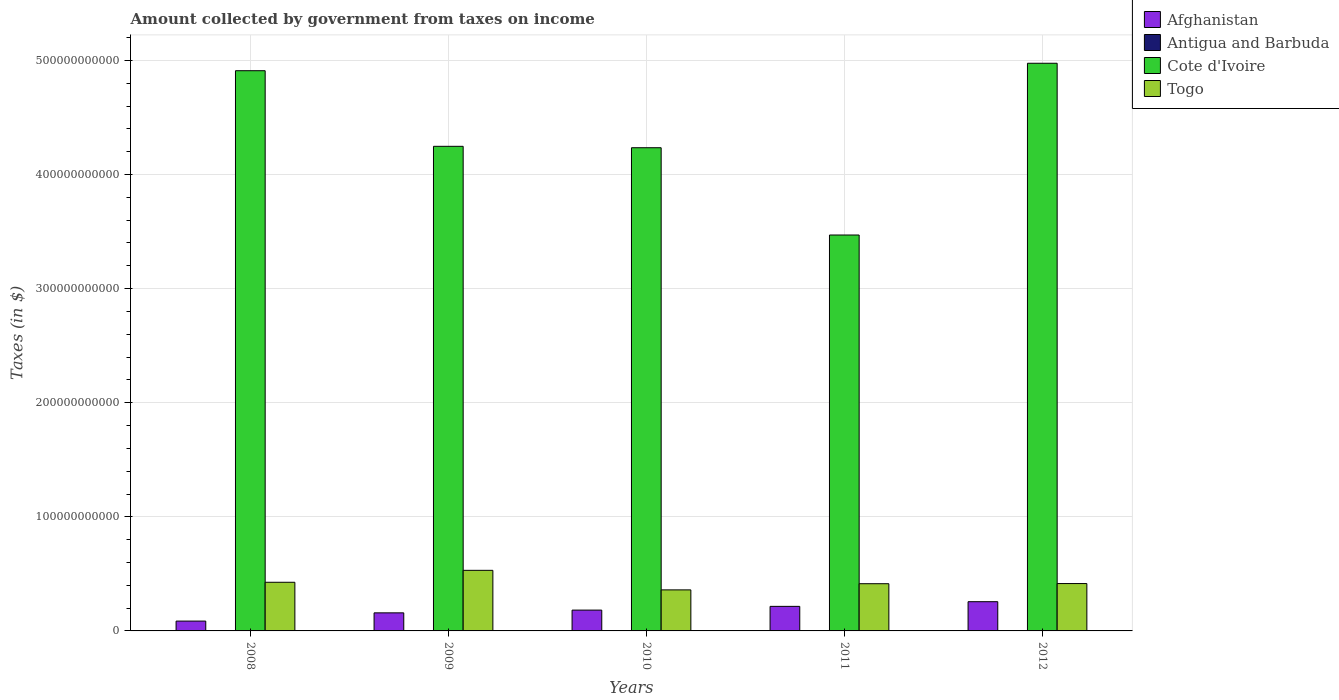How many groups of bars are there?
Your answer should be compact. 5. Are the number of bars per tick equal to the number of legend labels?
Provide a short and direct response. Yes. What is the label of the 1st group of bars from the left?
Offer a very short reply. 2008. In how many cases, is the number of bars for a given year not equal to the number of legend labels?
Provide a short and direct response. 0. What is the amount collected by government from taxes on income in Cote d'Ivoire in 2009?
Your answer should be very brief. 4.25e+11. Across all years, what is the maximum amount collected by government from taxes on income in Antigua and Barbuda?
Provide a short and direct response. 1.12e+08. Across all years, what is the minimum amount collected by government from taxes on income in Cote d'Ivoire?
Keep it short and to the point. 3.47e+11. In which year was the amount collected by government from taxes on income in Cote d'Ivoire minimum?
Provide a succinct answer. 2011. What is the total amount collected by government from taxes on income in Togo in the graph?
Offer a very short reply. 2.15e+11. What is the difference between the amount collected by government from taxes on income in Togo in 2008 and that in 2010?
Provide a short and direct response. 6.67e+09. What is the difference between the amount collected by government from taxes on income in Cote d'Ivoire in 2011 and the amount collected by government from taxes on income in Antigua and Barbuda in 2010?
Your answer should be very brief. 3.47e+11. What is the average amount collected by government from taxes on income in Togo per year?
Provide a short and direct response. 4.29e+1. In the year 2011, what is the difference between the amount collected by government from taxes on income in Antigua and Barbuda and amount collected by government from taxes on income in Afghanistan?
Your response must be concise. -2.14e+1. In how many years, is the amount collected by government from taxes on income in Togo greater than 60000000000 $?
Provide a short and direct response. 0. What is the ratio of the amount collected by government from taxes on income in Togo in 2008 to that in 2010?
Your answer should be very brief. 1.19. Is the difference between the amount collected by government from taxes on income in Antigua and Barbuda in 2008 and 2011 greater than the difference between the amount collected by government from taxes on income in Afghanistan in 2008 and 2011?
Keep it short and to the point. Yes. What is the difference between the highest and the second highest amount collected by government from taxes on income in Afghanistan?
Your answer should be very brief. 4.09e+09. What is the difference between the highest and the lowest amount collected by government from taxes on income in Afghanistan?
Give a very brief answer. 1.70e+1. What does the 1st bar from the left in 2010 represents?
Make the answer very short. Afghanistan. What does the 3rd bar from the right in 2009 represents?
Give a very brief answer. Antigua and Barbuda. How many bars are there?
Keep it short and to the point. 20. How many years are there in the graph?
Offer a very short reply. 5. What is the difference between two consecutive major ticks on the Y-axis?
Make the answer very short. 1.00e+11. Does the graph contain grids?
Your answer should be very brief. Yes. Where does the legend appear in the graph?
Provide a short and direct response. Top right. How many legend labels are there?
Make the answer very short. 4. How are the legend labels stacked?
Offer a very short reply. Vertical. What is the title of the graph?
Your answer should be very brief. Amount collected by government from taxes on income. Does "Ukraine" appear as one of the legend labels in the graph?
Give a very brief answer. No. What is the label or title of the X-axis?
Your response must be concise. Years. What is the label or title of the Y-axis?
Provide a short and direct response. Taxes (in $). What is the Taxes (in $) of Afghanistan in 2008?
Provide a succinct answer. 8.62e+09. What is the Taxes (in $) of Antigua and Barbuda in 2008?
Provide a succinct answer. 1.12e+08. What is the Taxes (in $) of Cote d'Ivoire in 2008?
Offer a terse response. 4.91e+11. What is the Taxes (in $) in Togo in 2008?
Your answer should be compact. 4.26e+1. What is the Taxes (in $) of Afghanistan in 2009?
Offer a terse response. 1.58e+1. What is the Taxes (in $) in Antigua and Barbuda in 2009?
Keep it short and to the point. 9.80e+07. What is the Taxes (in $) of Cote d'Ivoire in 2009?
Ensure brevity in your answer.  4.25e+11. What is the Taxes (in $) in Togo in 2009?
Provide a short and direct response. 5.31e+1. What is the Taxes (in $) in Afghanistan in 2010?
Offer a very short reply. 1.82e+1. What is the Taxes (in $) of Antigua and Barbuda in 2010?
Give a very brief answer. 9.24e+07. What is the Taxes (in $) in Cote d'Ivoire in 2010?
Give a very brief answer. 4.24e+11. What is the Taxes (in $) in Togo in 2010?
Offer a terse response. 3.60e+1. What is the Taxes (in $) in Afghanistan in 2011?
Ensure brevity in your answer.  2.15e+1. What is the Taxes (in $) in Antigua and Barbuda in 2011?
Your response must be concise. 6.97e+07. What is the Taxes (in $) in Cote d'Ivoire in 2011?
Keep it short and to the point. 3.47e+11. What is the Taxes (in $) in Togo in 2011?
Make the answer very short. 4.14e+1. What is the Taxes (in $) in Afghanistan in 2012?
Provide a short and direct response. 2.56e+1. What is the Taxes (in $) of Antigua and Barbuda in 2012?
Offer a very short reply. 7.73e+07. What is the Taxes (in $) of Cote d'Ivoire in 2012?
Your response must be concise. 4.98e+11. What is the Taxes (in $) of Togo in 2012?
Provide a succinct answer. 4.15e+1. Across all years, what is the maximum Taxes (in $) in Afghanistan?
Make the answer very short. 2.56e+1. Across all years, what is the maximum Taxes (in $) of Antigua and Barbuda?
Make the answer very short. 1.12e+08. Across all years, what is the maximum Taxes (in $) in Cote d'Ivoire?
Offer a terse response. 4.98e+11. Across all years, what is the maximum Taxes (in $) in Togo?
Give a very brief answer. 5.31e+1. Across all years, what is the minimum Taxes (in $) of Afghanistan?
Offer a very short reply. 8.62e+09. Across all years, what is the minimum Taxes (in $) of Antigua and Barbuda?
Offer a terse response. 6.97e+07. Across all years, what is the minimum Taxes (in $) of Cote d'Ivoire?
Your answer should be very brief. 3.47e+11. Across all years, what is the minimum Taxes (in $) of Togo?
Ensure brevity in your answer.  3.60e+1. What is the total Taxes (in $) in Afghanistan in the graph?
Give a very brief answer. 8.98e+1. What is the total Taxes (in $) in Antigua and Barbuda in the graph?
Make the answer very short. 4.49e+08. What is the total Taxes (in $) in Cote d'Ivoire in the graph?
Your answer should be very brief. 2.18e+12. What is the total Taxes (in $) of Togo in the graph?
Offer a terse response. 2.15e+11. What is the difference between the Taxes (in $) in Afghanistan in 2008 and that in 2009?
Your answer should be very brief. -7.23e+09. What is the difference between the Taxes (in $) in Antigua and Barbuda in 2008 and that in 2009?
Keep it short and to the point. 1.35e+07. What is the difference between the Taxes (in $) of Cote d'Ivoire in 2008 and that in 2009?
Provide a short and direct response. 6.63e+1. What is the difference between the Taxes (in $) in Togo in 2008 and that in 2009?
Make the answer very short. -1.05e+1. What is the difference between the Taxes (in $) in Afghanistan in 2008 and that in 2010?
Your response must be concise. -9.63e+09. What is the difference between the Taxes (in $) in Antigua and Barbuda in 2008 and that in 2010?
Make the answer very short. 1.91e+07. What is the difference between the Taxes (in $) of Cote d'Ivoire in 2008 and that in 2010?
Your answer should be compact. 6.75e+1. What is the difference between the Taxes (in $) of Togo in 2008 and that in 2010?
Keep it short and to the point. 6.67e+09. What is the difference between the Taxes (in $) in Afghanistan in 2008 and that in 2011?
Keep it short and to the point. -1.29e+1. What is the difference between the Taxes (in $) in Antigua and Barbuda in 2008 and that in 2011?
Your answer should be compact. 4.18e+07. What is the difference between the Taxes (in $) in Cote d'Ivoire in 2008 and that in 2011?
Give a very brief answer. 1.44e+11. What is the difference between the Taxes (in $) in Togo in 2008 and that in 2011?
Give a very brief answer. 1.26e+09. What is the difference between the Taxes (in $) of Afghanistan in 2008 and that in 2012?
Provide a short and direct response. -1.70e+1. What is the difference between the Taxes (in $) in Antigua and Barbuda in 2008 and that in 2012?
Your answer should be very brief. 3.42e+07. What is the difference between the Taxes (in $) in Cote d'Ivoire in 2008 and that in 2012?
Offer a terse response. -6.53e+09. What is the difference between the Taxes (in $) of Togo in 2008 and that in 2012?
Keep it short and to the point. 1.12e+09. What is the difference between the Taxes (in $) of Afghanistan in 2009 and that in 2010?
Your answer should be compact. -2.41e+09. What is the difference between the Taxes (in $) in Antigua and Barbuda in 2009 and that in 2010?
Your answer should be compact. 5.60e+06. What is the difference between the Taxes (in $) of Cote d'Ivoire in 2009 and that in 2010?
Your answer should be compact. 1.24e+09. What is the difference between the Taxes (in $) in Togo in 2009 and that in 2010?
Your response must be concise. 1.71e+1. What is the difference between the Taxes (in $) of Afghanistan in 2009 and that in 2011?
Make the answer very short. -5.68e+09. What is the difference between the Taxes (in $) in Antigua and Barbuda in 2009 and that in 2011?
Keep it short and to the point. 2.83e+07. What is the difference between the Taxes (in $) in Cote d'Ivoire in 2009 and that in 2011?
Give a very brief answer. 7.77e+1. What is the difference between the Taxes (in $) of Togo in 2009 and that in 2011?
Provide a short and direct response. 1.17e+1. What is the difference between the Taxes (in $) in Afghanistan in 2009 and that in 2012?
Give a very brief answer. -9.77e+09. What is the difference between the Taxes (in $) in Antigua and Barbuda in 2009 and that in 2012?
Ensure brevity in your answer.  2.07e+07. What is the difference between the Taxes (in $) in Cote d'Ivoire in 2009 and that in 2012?
Your response must be concise. -7.28e+1. What is the difference between the Taxes (in $) in Togo in 2009 and that in 2012?
Keep it short and to the point. 1.16e+1. What is the difference between the Taxes (in $) of Afghanistan in 2010 and that in 2011?
Your answer should be very brief. -3.27e+09. What is the difference between the Taxes (in $) of Antigua and Barbuda in 2010 and that in 2011?
Make the answer very short. 2.27e+07. What is the difference between the Taxes (in $) in Cote d'Ivoire in 2010 and that in 2011?
Your answer should be very brief. 7.65e+1. What is the difference between the Taxes (in $) in Togo in 2010 and that in 2011?
Provide a short and direct response. -5.41e+09. What is the difference between the Taxes (in $) of Afghanistan in 2010 and that in 2012?
Make the answer very short. -7.36e+09. What is the difference between the Taxes (in $) of Antigua and Barbuda in 2010 and that in 2012?
Offer a very short reply. 1.51e+07. What is the difference between the Taxes (in $) in Cote d'Ivoire in 2010 and that in 2012?
Offer a very short reply. -7.40e+1. What is the difference between the Taxes (in $) in Togo in 2010 and that in 2012?
Provide a short and direct response. -5.55e+09. What is the difference between the Taxes (in $) of Afghanistan in 2011 and that in 2012?
Provide a short and direct response. -4.09e+09. What is the difference between the Taxes (in $) of Antigua and Barbuda in 2011 and that in 2012?
Give a very brief answer. -7.60e+06. What is the difference between the Taxes (in $) of Cote d'Ivoire in 2011 and that in 2012?
Your answer should be compact. -1.51e+11. What is the difference between the Taxes (in $) in Togo in 2011 and that in 2012?
Offer a terse response. -1.35e+08. What is the difference between the Taxes (in $) of Afghanistan in 2008 and the Taxes (in $) of Antigua and Barbuda in 2009?
Ensure brevity in your answer.  8.52e+09. What is the difference between the Taxes (in $) in Afghanistan in 2008 and the Taxes (in $) in Cote d'Ivoire in 2009?
Your response must be concise. -4.16e+11. What is the difference between the Taxes (in $) of Afghanistan in 2008 and the Taxes (in $) of Togo in 2009?
Provide a succinct answer. -4.45e+1. What is the difference between the Taxes (in $) in Antigua and Barbuda in 2008 and the Taxes (in $) in Cote d'Ivoire in 2009?
Offer a very short reply. -4.25e+11. What is the difference between the Taxes (in $) of Antigua and Barbuda in 2008 and the Taxes (in $) of Togo in 2009?
Keep it short and to the point. -5.30e+1. What is the difference between the Taxes (in $) of Cote d'Ivoire in 2008 and the Taxes (in $) of Togo in 2009?
Give a very brief answer. 4.38e+11. What is the difference between the Taxes (in $) of Afghanistan in 2008 and the Taxes (in $) of Antigua and Barbuda in 2010?
Your answer should be very brief. 8.52e+09. What is the difference between the Taxes (in $) of Afghanistan in 2008 and the Taxes (in $) of Cote d'Ivoire in 2010?
Make the answer very short. -4.15e+11. What is the difference between the Taxes (in $) of Afghanistan in 2008 and the Taxes (in $) of Togo in 2010?
Offer a terse response. -2.74e+1. What is the difference between the Taxes (in $) of Antigua and Barbuda in 2008 and the Taxes (in $) of Cote d'Ivoire in 2010?
Offer a very short reply. -4.23e+11. What is the difference between the Taxes (in $) in Antigua and Barbuda in 2008 and the Taxes (in $) in Togo in 2010?
Provide a succinct answer. -3.59e+1. What is the difference between the Taxes (in $) in Cote d'Ivoire in 2008 and the Taxes (in $) in Togo in 2010?
Provide a short and direct response. 4.55e+11. What is the difference between the Taxes (in $) in Afghanistan in 2008 and the Taxes (in $) in Antigua and Barbuda in 2011?
Keep it short and to the point. 8.55e+09. What is the difference between the Taxes (in $) of Afghanistan in 2008 and the Taxes (in $) of Cote d'Ivoire in 2011?
Your answer should be compact. -3.38e+11. What is the difference between the Taxes (in $) of Afghanistan in 2008 and the Taxes (in $) of Togo in 2011?
Offer a very short reply. -3.28e+1. What is the difference between the Taxes (in $) of Antigua and Barbuda in 2008 and the Taxes (in $) of Cote d'Ivoire in 2011?
Your answer should be compact. -3.47e+11. What is the difference between the Taxes (in $) of Antigua and Barbuda in 2008 and the Taxes (in $) of Togo in 2011?
Ensure brevity in your answer.  -4.13e+1. What is the difference between the Taxes (in $) in Cote d'Ivoire in 2008 and the Taxes (in $) in Togo in 2011?
Your response must be concise. 4.50e+11. What is the difference between the Taxes (in $) in Afghanistan in 2008 and the Taxes (in $) in Antigua and Barbuda in 2012?
Give a very brief answer. 8.54e+09. What is the difference between the Taxes (in $) in Afghanistan in 2008 and the Taxes (in $) in Cote d'Ivoire in 2012?
Provide a succinct answer. -4.89e+11. What is the difference between the Taxes (in $) of Afghanistan in 2008 and the Taxes (in $) of Togo in 2012?
Make the answer very short. -3.29e+1. What is the difference between the Taxes (in $) of Antigua and Barbuda in 2008 and the Taxes (in $) of Cote d'Ivoire in 2012?
Give a very brief answer. -4.97e+11. What is the difference between the Taxes (in $) in Antigua and Barbuda in 2008 and the Taxes (in $) in Togo in 2012?
Your response must be concise. -4.14e+1. What is the difference between the Taxes (in $) of Cote d'Ivoire in 2008 and the Taxes (in $) of Togo in 2012?
Your answer should be compact. 4.49e+11. What is the difference between the Taxes (in $) in Afghanistan in 2009 and the Taxes (in $) in Antigua and Barbuda in 2010?
Your response must be concise. 1.57e+1. What is the difference between the Taxes (in $) of Afghanistan in 2009 and the Taxes (in $) of Cote d'Ivoire in 2010?
Your answer should be compact. -4.08e+11. What is the difference between the Taxes (in $) in Afghanistan in 2009 and the Taxes (in $) in Togo in 2010?
Provide a succinct answer. -2.01e+1. What is the difference between the Taxes (in $) of Antigua and Barbuda in 2009 and the Taxes (in $) of Cote d'Ivoire in 2010?
Give a very brief answer. -4.23e+11. What is the difference between the Taxes (in $) in Antigua and Barbuda in 2009 and the Taxes (in $) in Togo in 2010?
Give a very brief answer. -3.59e+1. What is the difference between the Taxes (in $) of Cote d'Ivoire in 2009 and the Taxes (in $) of Togo in 2010?
Your answer should be compact. 3.89e+11. What is the difference between the Taxes (in $) of Afghanistan in 2009 and the Taxes (in $) of Antigua and Barbuda in 2011?
Your answer should be compact. 1.58e+1. What is the difference between the Taxes (in $) in Afghanistan in 2009 and the Taxes (in $) in Cote d'Ivoire in 2011?
Offer a terse response. -3.31e+11. What is the difference between the Taxes (in $) of Afghanistan in 2009 and the Taxes (in $) of Togo in 2011?
Your response must be concise. -2.55e+1. What is the difference between the Taxes (in $) of Antigua and Barbuda in 2009 and the Taxes (in $) of Cote d'Ivoire in 2011?
Offer a terse response. -3.47e+11. What is the difference between the Taxes (in $) of Antigua and Barbuda in 2009 and the Taxes (in $) of Togo in 2011?
Provide a short and direct response. -4.13e+1. What is the difference between the Taxes (in $) of Cote d'Ivoire in 2009 and the Taxes (in $) of Togo in 2011?
Offer a terse response. 3.83e+11. What is the difference between the Taxes (in $) of Afghanistan in 2009 and the Taxes (in $) of Antigua and Barbuda in 2012?
Ensure brevity in your answer.  1.58e+1. What is the difference between the Taxes (in $) in Afghanistan in 2009 and the Taxes (in $) in Cote d'Ivoire in 2012?
Keep it short and to the point. -4.82e+11. What is the difference between the Taxes (in $) of Afghanistan in 2009 and the Taxes (in $) of Togo in 2012?
Make the answer very short. -2.57e+1. What is the difference between the Taxes (in $) of Antigua and Barbuda in 2009 and the Taxes (in $) of Cote d'Ivoire in 2012?
Provide a short and direct response. -4.97e+11. What is the difference between the Taxes (in $) of Antigua and Barbuda in 2009 and the Taxes (in $) of Togo in 2012?
Give a very brief answer. -4.14e+1. What is the difference between the Taxes (in $) of Cote d'Ivoire in 2009 and the Taxes (in $) of Togo in 2012?
Provide a succinct answer. 3.83e+11. What is the difference between the Taxes (in $) in Afghanistan in 2010 and the Taxes (in $) in Antigua and Barbuda in 2011?
Your answer should be compact. 1.82e+1. What is the difference between the Taxes (in $) in Afghanistan in 2010 and the Taxes (in $) in Cote d'Ivoire in 2011?
Offer a terse response. -3.29e+11. What is the difference between the Taxes (in $) of Afghanistan in 2010 and the Taxes (in $) of Togo in 2011?
Provide a succinct answer. -2.31e+1. What is the difference between the Taxes (in $) of Antigua and Barbuda in 2010 and the Taxes (in $) of Cote d'Ivoire in 2011?
Provide a short and direct response. -3.47e+11. What is the difference between the Taxes (in $) in Antigua and Barbuda in 2010 and the Taxes (in $) in Togo in 2011?
Make the answer very short. -4.13e+1. What is the difference between the Taxes (in $) in Cote d'Ivoire in 2010 and the Taxes (in $) in Togo in 2011?
Your response must be concise. 3.82e+11. What is the difference between the Taxes (in $) of Afghanistan in 2010 and the Taxes (in $) of Antigua and Barbuda in 2012?
Offer a very short reply. 1.82e+1. What is the difference between the Taxes (in $) in Afghanistan in 2010 and the Taxes (in $) in Cote d'Ivoire in 2012?
Offer a terse response. -4.79e+11. What is the difference between the Taxes (in $) in Afghanistan in 2010 and the Taxes (in $) in Togo in 2012?
Ensure brevity in your answer.  -2.33e+1. What is the difference between the Taxes (in $) in Antigua and Barbuda in 2010 and the Taxes (in $) in Cote d'Ivoire in 2012?
Your answer should be very brief. -4.97e+11. What is the difference between the Taxes (in $) in Antigua and Barbuda in 2010 and the Taxes (in $) in Togo in 2012?
Offer a very short reply. -4.14e+1. What is the difference between the Taxes (in $) of Cote d'Ivoire in 2010 and the Taxes (in $) of Togo in 2012?
Provide a short and direct response. 3.82e+11. What is the difference between the Taxes (in $) of Afghanistan in 2011 and the Taxes (in $) of Antigua and Barbuda in 2012?
Your answer should be very brief. 2.14e+1. What is the difference between the Taxes (in $) in Afghanistan in 2011 and the Taxes (in $) in Cote d'Ivoire in 2012?
Give a very brief answer. -4.76e+11. What is the difference between the Taxes (in $) of Afghanistan in 2011 and the Taxes (in $) of Togo in 2012?
Make the answer very short. -2.00e+1. What is the difference between the Taxes (in $) in Antigua and Barbuda in 2011 and the Taxes (in $) in Cote d'Ivoire in 2012?
Offer a terse response. -4.97e+11. What is the difference between the Taxes (in $) in Antigua and Barbuda in 2011 and the Taxes (in $) in Togo in 2012?
Give a very brief answer. -4.14e+1. What is the difference between the Taxes (in $) of Cote d'Ivoire in 2011 and the Taxes (in $) of Togo in 2012?
Provide a short and direct response. 3.05e+11. What is the average Taxes (in $) in Afghanistan per year?
Your answer should be compact. 1.80e+1. What is the average Taxes (in $) in Antigua and Barbuda per year?
Offer a terse response. 8.98e+07. What is the average Taxes (in $) in Cote d'Ivoire per year?
Your answer should be very brief. 4.37e+11. What is the average Taxes (in $) in Togo per year?
Your answer should be very brief. 4.29e+1. In the year 2008, what is the difference between the Taxes (in $) of Afghanistan and Taxes (in $) of Antigua and Barbuda?
Offer a very short reply. 8.50e+09. In the year 2008, what is the difference between the Taxes (in $) of Afghanistan and Taxes (in $) of Cote d'Ivoire?
Offer a very short reply. -4.82e+11. In the year 2008, what is the difference between the Taxes (in $) in Afghanistan and Taxes (in $) in Togo?
Ensure brevity in your answer.  -3.40e+1. In the year 2008, what is the difference between the Taxes (in $) in Antigua and Barbuda and Taxes (in $) in Cote d'Ivoire?
Provide a short and direct response. -4.91e+11. In the year 2008, what is the difference between the Taxes (in $) of Antigua and Barbuda and Taxes (in $) of Togo?
Your response must be concise. -4.25e+1. In the year 2008, what is the difference between the Taxes (in $) in Cote d'Ivoire and Taxes (in $) in Togo?
Offer a terse response. 4.48e+11. In the year 2009, what is the difference between the Taxes (in $) in Afghanistan and Taxes (in $) in Antigua and Barbuda?
Provide a short and direct response. 1.57e+1. In the year 2009, what is the difference between the Taxes (in $) of Afghanistan and Taxes (in $) of Cote d'Ivoire?
Offer a terse response. -4.09e+11. In the year 2009, what is the difference between the Taxes (in $) of Afghanistan and Taxes (in $) of Togo?
Make the answer very short. -3.73e+1. In the year 2009, what is the difference between the Taxes (in $) of Antigua and Barbuda and Taxes (in $) of Cote d'Ivoire?
Provide a short and direct response. -4.25e+11. In the year 2009, what is the difference between the Taxes (in $) of Antigua and Barbuda and Taxes (in $) of Togo?
Ensure brevity in your answer.  -5.30e+1. In the year 2009, what is the difference between the Taxes (in $) of Cote d'Ivoire and Taxes (in $) of Togo?
Make the answer very short. 3.72e+11. In the year 2010, what is the difference between the Taxes (in $) in Afghanistan and Taxes (in $) in Antigua and Barbuda?
Ensure brevity in your answer.  1.82e+1. In the year 2010, what is the difference between the Taxes (in $) in Afghanistan and Taxes (in $) in Cote d'Ivoire?
Provide a succinct answer. -4.05e+11. In the year 2010, what is the difference between the Taxes (in $) of Afghanistan and Taxes (in $) of Togo?
Ensure brevity in your answer.  -1.77e+1. In the year 2010, what is the difference between the Taxes (in $) in Antigua and Barbuda and Taxes (in $) in Cote d'Ivoire?
Make the answer very short. -4.23e+11. In the year 2010, what is the difference between the Taxes (in $) of Antigua and Barbuda and Taxes (in $) of Togo?
Offer a terse response. -3.59e+1. In the year 2010, what is the difference between the Taxes (in $) in Cote d'Ivoire and Taxes (in $) in Togo?
Give a very brief answer. 3.88e+11. In the year 2011, what is the difference between the Taxes (in $) of Afghanistan and Taxes (in $) of Antigua and Barbuda?
Give a very brief answer. 2.14e+1. In the year 2011, what is the difference between the Taxes (in $) in Afghanistan and Taxes (in $) in Cote d'Ivoire?
Provide a succinct answer. -3.25e+11. In the year 2011, what is the difference between the Taxes (in $) of Afghanistan and Taxes (in $) of Togo?
Offer a terse response. -1.99e+1. In the year 2011, what is the difference between the Taxes (in $) of Antigua and Barbuda and Taxes (in $) of Cote d'Ivoire?
Ensure brevity in your answer.  -3.47e+11. In the year 2011, what is the difference between the Taxes (in $) of Antigua and Barbuda and Taxes (in $) of Togo?
Provide a short and direct response. -4.13e+1. In the year 2011, what is the difference between the Taxes (in $) of Cote d'Ivoire and Taxes (in $) of Togo?
Offer a very short reply. 3.06e+11. In the year 2012, what is the difference between the Taxes (in $) in Afghanistan and Taxes (in $) in Antigua and Barbuda?
Ensure brevity in your answer.  2.55e+1. In the year 2012, what is the difference between the Taxes (in $) in Afghanistan and Taxes (in $) in Cote d'Ivoire?
Make the answer very short. -4.72e+11. In the year 2012, what is the difference between the Taxes (in $) in Afghanistan and Taxes (in $) in Togo?
Offer a terse response. -1.59e+1. In the year 2012, what is the difference between the Taxes (in $) in Antigua and Barbuda and Taxes (in $) in Cote d'Ivoire?
Provide a succinct answer. -4.97e+11. In the year 2012, what is the difference between the Taxes (in $) in Antigua and Barbuda and Taxes (in $) in Togo?
Your response must be concise. -4.14e+1. In the year 2012, what is the difference between the Taxes (in $) of Cote d'Ivoire and Taxes (in $) of Togo?
Offer a terse response. 4.56e+11. What is the ratio of the Taxes (in $) in Afghanistan in 2008 to that in 2009?
Offer a very short reply. 0.54. What is the ratio of the Taxes (in $) of Antigua and Barbuda in 2008 to that in 2009?
Provide a short and direct response. 1.14. What is the ratio of the Taxes (in $) in Cote d'Ivoire in 2008 to that in 2009?
Your answer should be very brief. 1.16. What is the ratio of the Taxes (in $) in Togo in 2008 to that in 2009?
Offer a very short reply. 0.8. What is the ratio of the Taxes (in $) of Afghanistan in 2008 to that in 2010?
Ensure brevity in your answer.  0.47. What is the ratio of the Taxes (in $) of Antigua and Barbuda in 2008 to that in 2010?
Make the answer very short. 1.21. What is the ratio of the Taxes (in $) in Cote d'Ivoire in 2008 to that in 2010?
Make the answer very short. 1.16. What is the ratio of the Taxes (in $) of Togo in 2008 to that in 2010?
Give a very brief answer. 1.19. What is the ratio of the Taxes (in $) in Afghanistan in 2008 to that in 2011?
Keep it short and to the point. 0.4. What is the ratio of the Taxes (in $) in Antigua and Barbuda in 2008 to that in 2011?
Make the answer very short. 1.6. What is the ratio of the Taxes (in $) in Cote d'Ivoire in 2008 to that in 2011?
Provide a short and direct response. 1.42. What is the ratio of the Taxes (in $) of Togo in 2008 to that in 2011?
Your answer should be very brief. 1.03. What is the ratio of the Taxes (in $) of Afghanistan in 2008 to that in 2012?
Offer a terse response. 0.34. What is the ratio of the Taxes (in $) in Antigua and Barbuda in 2008 to that in 2012?
Provide a short and direct response. 1.44. What is the ratio of the Taxes (in $) of Cote d'Ivoire in 2008 to that in 2012?
Your answer should be compact. 0.99. What is the ratio of the Taxes (in $) in Afghanistan in 2009 to that in 2010?
Offer a very short reply. 0.87. What is the ratio of the Taxes (in $) in Antigua and Barbuda in 2009 to that in 2010?
Provide a short and direct response. 1.06. What is the ratio of the Taxes (in $) of Cote d'Ivoire in 2009 to that in 2010?
Offer a terse response. 1. What is the ratio of the Taxes (in $) of Togo in 2009 to that in 2010?
Keep it short and to the point. 1.48. What is the ratio of the Taxes (in $) in Afghanistan in 2009 to that in 2011?
Keep it short and to the point. 0.74. What is the ratio of the Taxes (in $) of Antigua and Barbuda in 2009 to that in 2011?
Provide a succinct answer. 1.41. What is the ratio of the Taxes (in $) in Cote d'Ivoire in 2009 to that in 2011?
Give a very brief answer. 1.22. What is the ratio of the Taxes (in $) in Togo in 2009 to that in 2011?
Your answer should be compact. 1.28. What is the ratio of the Taxes (in $) in Afghanistan in 2009 to that in 2012?
Ensure brevity in your answer.  0.62. What is the ratio of the Taxes (in $) in Antigua and Barbuda in 2009 to that in 2012?
Offer a terse response. 1.27. What is the ratio of the Taxes (in $) of Cote d'Ivoire in 2009 to that in 2012?
Offer a terse response. 0.85. What is the ratio of the Taxes (in $) in Togo in 2009 to that in 2012?
Make the answer very short. 1.28. What is the ratio of the Taxes (in $) in Afghanistan in 2010 to that in 2011?
Ensure brevity in your answer.  0.85. What is the ratio of the Taxes (in $) in Antigua and Barbuda in 2010 to that in 2011?
Give a very brief answer. 1.33. What is the ratio of the Taxes (in $) of Cote d'Ivoire in 2010 to that in 2011?
Keep it short and to the point. 1.22. What is the ratio of the Taxes (in $) of Togo in 2010 to that in 2011?
Provide a succinct answer. 0.87. What is the ratio of the Taxes (in $) of Afghanistan in 2010 to that in 2012?
Offer a very short reply. 0.71. What is the ratio of the Taxes (in $) in Antigua and Barbuda in 2010 to that in 2012?
Your response must be concise. 1.2. What is the ratio of the Taxes (in $) in Cote d'Ivoire in 2010 to that in 2012?
Your response must be concise. 0.85. What is the ratio of the Taxes (in $) in Togo in 2010 to that in 2012?
Ensure brevity in your answer.  0.87. What is the ratio of the Taxes (in $) of Afghanistan in 2011 to that in 2012?
Provide a succinct answer. 0.84. What is the ratio of the Taxes (in $) in Antigua and Barbuda in 2011 to that in 2012?
Offer a very short reply. 0.9. What is the ratio of the Taxes (in $) of Cote d'Ivoire in 2011 to that in 2012?
Make the answer very short. 0.7. What is the difference between the highest and the second highest Taxes (in $) in Afghanistan?
Ensure brevity in your answer.  4.09e+09. What is the difference between the highest and the second highest Taxes (in $) of Antigua and Barbuda?
Offer a very short reply. 1.35e+07. What is the difference between the highest and the second highest Taxes (in $) in Cote d'Ivoire?
Your answer should be compact. 6.53e+09. What is the difference between the highest and the second highest Taxes (in $) in Togo?
Ensure brevity in your answer.  1.05e+1. What is the difference between the highest and the lowest Taxes (in $) in Afghanistan?
Your response must be concise. 1.70e+1. What is the difference between the highest and the lowest Taxes (in $) of Antigua and Barbuda?
Offer a very short reply. 4.18e+07. What is the difference between the highest and the lowest Taxes (in $) in Cote d'Ivoire?
Offer a terse response. 1.51e+11. What is the difference between the highest and the lowest Taxes (in $) of Togo?
Your response must be concise. 1.71e+1. 